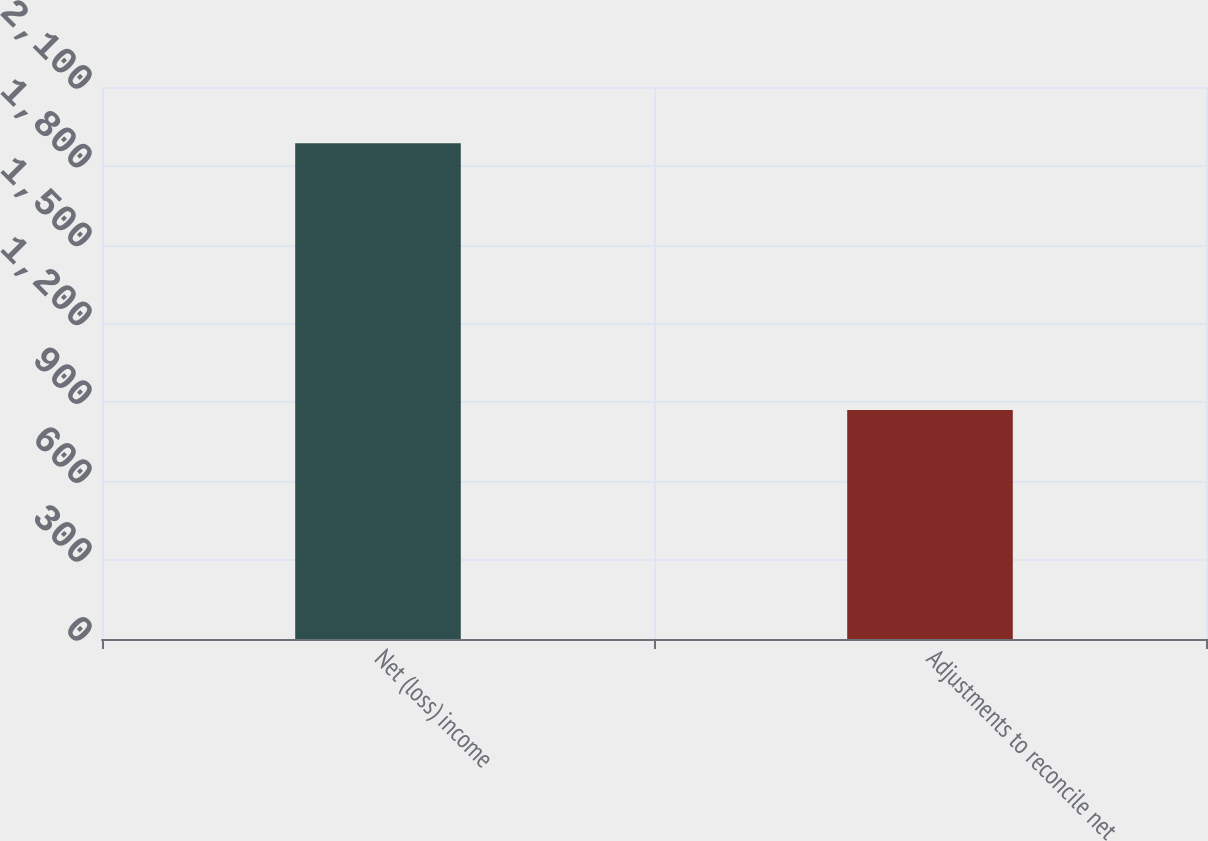<chart> <loc_0><loc_0><loc_500><loc_500><bar_chart><fcel>Net (loss) income<fcel>Adjustments to reconcile net<nl><fcel>1886<fcel>871<nl></chart> 